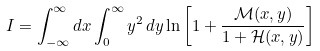<formula> <loc_0><loc_0><loc_500><loc_500>I = \int _ { - \infty } ^ { \infty } d x \int _ { 0 } ^ { \infty } y ^ { 2 } \, d y \ln \left [ 1 + \frac { { \mathcal { M } } ( x , y ) } { 1 + { \mathcal { H } } ( x , y ) } \right ]</formula> 